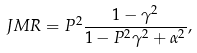<formula> <loc_0><loc_0><loc_500><loc_500>J M R = P ^ { 2 } \frac { 1 - \gamma ^ { 2 } } { 1 - P ^ { 2 } \gamma ^ { 2 } + \alpha ^ { 2 } } ,</formula> 